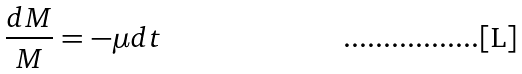<formula> <loc_0><loc_0><loc_500><loc_500>\frac { d M } { M } = - { \mu } d t</formula> 